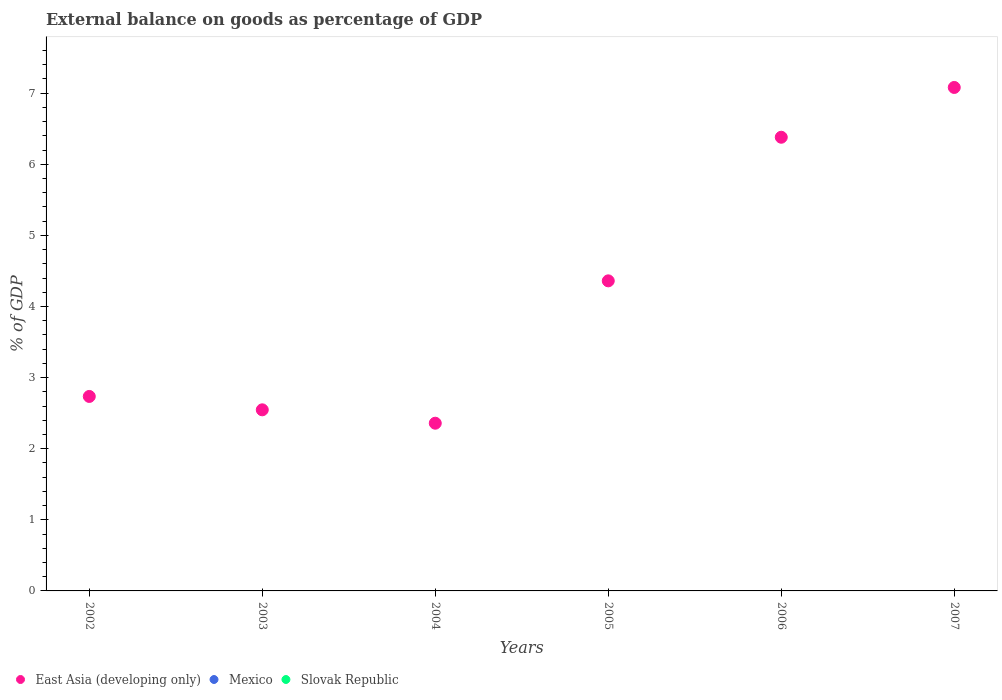How many different coloured dotlines are there?
Provide a succinct answer. 1. Is the number of dotlines equal to the number of legend labels?
Keep it short and to the point. No. What is the external balance on goods as percentage of GDP in East Asia (developing only) in 2004?
Provide a succinct answer. 2.36. Across all years, what is the maximum external balance on goods as percentage of GDP in East Asia (developing only)?
Offer a terse response. 7.08. What is the difference between the external balance on goods as percentage of GDP in East Asia (developing only) in 2002 and that in 2003?
Provide a succinct answer. 0.19. What is the average external balance on goods as percentage of GDP in Slovak Republic per year?
Ensure brevity in your answer.  0. In how many years, is the external balance on goods as percentage of GDP in Mexico greater than 5.2 %?
Your answer should be very brief. 0. What is the ratio of the external balance on goods as percentage of GDP in East Asia (developing only) in 2002 to that in 2003?
Provide a short and direct response. 1.07. Is the external balance on goods as percentage of GDP in East Asia (developing only) in 2005 less than that in 2006?
Keep it short and to the point. Yes. What is the difference between the highest and the second highest external balance on goods as percentage of GDP in East Asia (developing only)?
Your response must be concise. 0.7. What is the difference between the highest and the lowest external balance on goods as percentage of GDP in East Asia (developing only)?
Keep it short and to the point. 4.72. In how many years, is the external balance on goods as percentage of GDP in Mexico greater than the average external balance on goods as percentage of GDP in Mexico taken over all years?
Your answer should be very brief. 0. Is it the case that in every year, the sum of the external balance on goods as percentage of GDP in East Asia (developing only) and external balance on goods as percentage of GDP in Mexico  is greater than the external balance on goods as percentage of GDP in Slovak Republic?
Provide a succinct answer. Yes. Does the external balance on goods as percentage of GDP in East Asia (developing only) monotonically increase over the years?
Offer a very short reply. No. Is the external balance on goods as percentage of GDP in Mexico strictly greater than the external balance on goods as percentage of GDP in Slovak Republic over the years?
Offer a very short reply. No. Is the external balance on goods as percentage of GDP in Mexico strictly less than the external balance on goods as percentage of GDP in Slovak Republic over the years?
Your answer should be compact. No. How many legend labels are there?
Keep it short and to the point. 3. How are the legend labels stacked?
Your answer should be very brief. Horizontal. What is the title of the graph?
Provide a succinct answer. External balance on goods as percentage of GDP. What is the label or title of the X-axis?
Provide a succinct answer. Years. What is the label or title of the Y-axis?
Your response must be concise. % of GDP. What is the % of GDP in East Asia (developing only) in 2002?
Offer a very short reply. 2.74. What is the % of GDP of East Asia (developing only) in 2003?
Provide a short and direct response. 2.55. What is the % of GDP in Mexico in 2003?
Give a very brief answer. 0. What is the % of GDP of Slovak Republic in 2003?
Your response must be concise. 0. What is the % of GDP of East Asia (developing only) in 2004?
Your answer should be very brief. 2.36. What is the % of GDP of East Asia (developing only) in 2005?
Make the answer very short. 4.36. What is the % of GDP in Slovak Republic in 2005?
Offer a terse response. 0. What is the % of GDP of East Asia (developing only) in 2006?
Offer a very short reply. 6.38. What is the % of GDP of East Asia (developing only) in 2007?
Offer a terse response. 7.08. Across all years, what is the maximum % of GDP in East Asia (developing only)?
Your response must be concise. 7.08. Across all years, what is the minimum % of GDP of East Asia (developing only)?
Your answer should be very brief. 2.36. What is the total % of GDP of East Asia (developing only) in the graph?
Provide a short and direct response. 25.46. What is the total % of GDP of Mexico in the graph?
Keep it short and to the point. 0. What is the difference between the % of GDP in East Asia (developing only) in 2002 and that in 2003?
Make the answer very short. 0.19. What is the difference between the % of GDP in East Asia (developing only) in 2002 and that in 2004?
Provide a short and direct response. 0.38. What is the difference between the % of GDP in East Asia (developing only) in 2002 and that in 2005?
Provide a succinct answer. -1.63. What is the difference between the % of GDP of East Asia (developing only) in 2002 and that in 2006?
Offer a very short reply. -3.65. What is the difference between the % of GDP of East Asia (developing only) in 2002 and that in 2007?
Your response must be concise. -4.35. What is the difference between the % of GDP of East Asia (developing only) in 2003 and that in 2004?
Your answer should be compact. 0.19. What is the difference between the % of GDP of East Asia (developing only) in 2003 and that in 2005?
Offer a very short reply. -1.81. What is the difference between the % of GDP in East Asia (developing only) in 2003 and that in 2006?
Keep it short and to the point. -3.83. What is the difference between the % of GDP in East Asia (developing only) in 2003 and that in 2007?
Your answer should be compact. -4.53. What is the difference between the % of GDP in East Asia (developing only) in 2004 and that in 2005?
Offer a terse response. -2. What is the difference between the % of GDP in East Asia (developing only) in 2004 and that in 2006?
Offer a very short reply. -4.02. What is the difference between the % of GDP in East Asia (developing only) in 2004 and that in 2007?
Your response must be concise. -4.72. What is the difference between the % of GDP in East Asia (developing only) in 2005 and that in 2006?
Your response must be concise. -2.02. What is the difference between the % of GDP in East Asia (developing only) in 2005 and that in 2007?
Your response must be concise. -2.72. What is the difference between the % of GDP of East Asia (developing only) in 2006 and that in 2007?
Provide a short and direct response. -0.7. What is the average % of GDP in East Asia (developing only) per year?
Your answer should be compact. 4.24. What is the average % of GDP of Slovak Republic per year?
Your response must be concise. 0. What is the ratio of the % of GDP of East Asia (developing only) in 2002 to that in 2003?
Your answer should be very brief. 1.07. What is the ratio of the % of GDP of East Asia (developing only) in 2002 to that in 2004?
Provide a short and direct response. 1.16. What is the ratio of the % of GDP of East Asia (developing only) in 2002 to that in 2005?
Provide a succinct answer. 0.63. What is the ratio of the % of GDP of East Asia (developing only) in 2002 to that in 2006?
Keep it short and to the point. 0.43. What is the ratio of the % of GDP in East Asia (developing only) in 2002 to that in 2007?
Offer a terse response. 0.39. What is the ratio of the % of GDP of East Asia (developing only) in 2003 to that in 2004?
Keep it short and to the point. 1.08. What is the ratio of the % of GDP of East Asia (developing only) in 2003 to that in 2005?
Give a very brief answer. 0.58. What is the ratio of the % of GDP in East Asia (developing only) in 2003 to that in 2006?
Keep it short and to the point. 0.4. What is the ratio of the % of GDP in East Asia (developing only) in 2003 to that in 2007?
Make the answer very short. 0.36. What is the ratio of the % of GDP of East Asia (developing only) in 2004 to that in 2005?
Offer a terse response. 0.54. What is the ratio of the % of GDP of East Asia (developing only) in 2004 to that in 2006?
Keep it short and to the point. 0.37. What is the ratio of the % of GDP in East Asia (developing only) in 2004 to that in 2007?
Your answer should be compact. 0.33. What is the ratio of the % of GDP of East Asia (developing only) in 2005 to that in 2006?
Make the answer very short. 0.68. What is the ratio of the % of GDP in East Asia (developing only) in 2005 to that in 2007?
Make the answer very short. 0.62. What is the ratio of the % of GDP in East Asia (developing only) in 2006 to that in 2007?
Offer a very short reply. 0.9. What is the difference between the highest and the second highest % of GDP in East Asia (developing only)?
Keep it short and to the point. 0.7. What is the difference between the highest and the lowest % of GDP in East Asia (developing only)?
Keep it short and to the point. 4.72. 